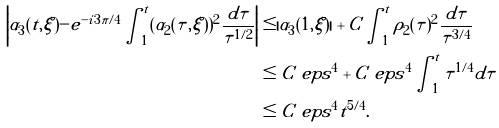Convert formula to latex. <formula><loc_0><loc_0><loc_500><loc_500>\left | \alpha _ { 3 } ( t , \xi ) - e ^ { - i 3 \pi / 4 } \int _ { 1 } ^ { t } ( \alpha _ { 2 } ( \tau , \xi ) ) ^ { 2 } \frac { d \tau } { \tau ^ { 1 / 2 } } \right | & \leq | \alpha _ { 3 } ( 1 , \xi ) | + C \int _ { 1 } ^ { t } \rho _ { 2 } ( \tau ) ^ { 2 } \frac { d \tau } { \tau ^ { 3 / 4 } } \\ & \leq C \ e p s ^ { 4 } + C \ e p s ^ { 4 } \int _ { 1 } ^ { t } \tau ^ { 1 / 4 } d \tau \\ & \leq C \ e p s ^ { 4 } t ^ { 5 / 4 } .</formula> 